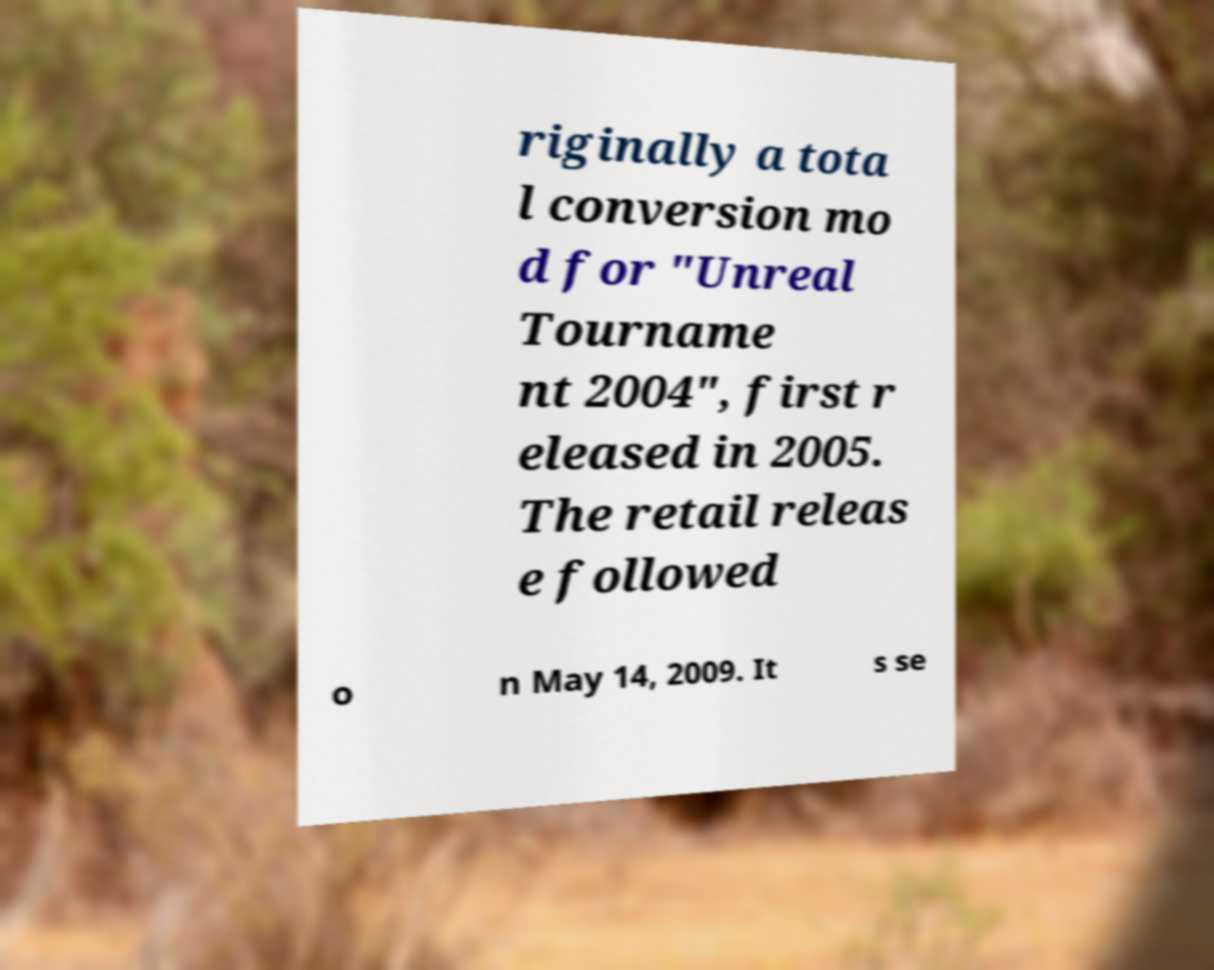Please read and relay the text visible in this image. What does it say? riginally a tota l conversion mo d for "Unreal Tourname nt 2004", first r eleased in 2005. The retail releas e followed o n May 14, 2009. It s se 